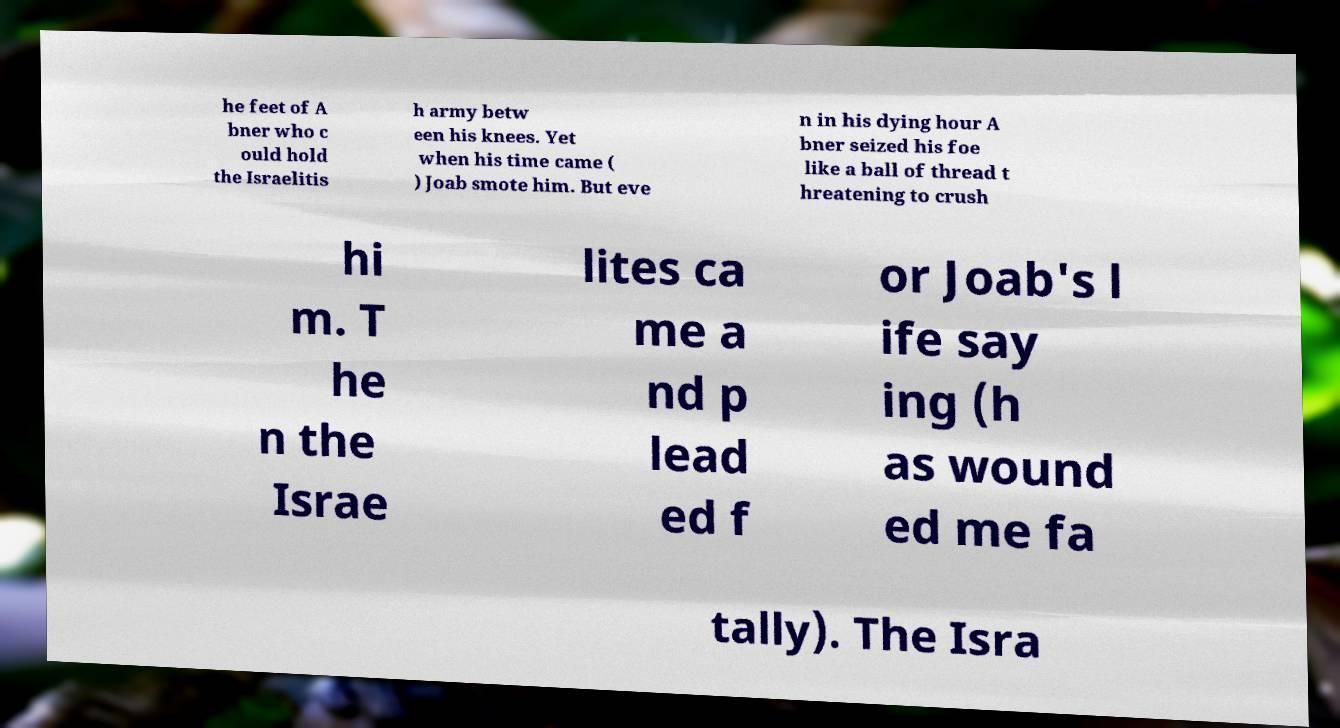Please read and relay the text visible in this image. What does it say? he feet of A bner who c ould hold the Israelitis h army betw een his knees. Yet when his time came ( ) Joab smote him. But eve n in his dying hour A bner seized his foe like a ball of thread t hreatening to crush hi m. T he n the Israe lites ca me a nd p lead ed f or Joab's l ife say ing (h as wound ed me fa tally). The Isra 